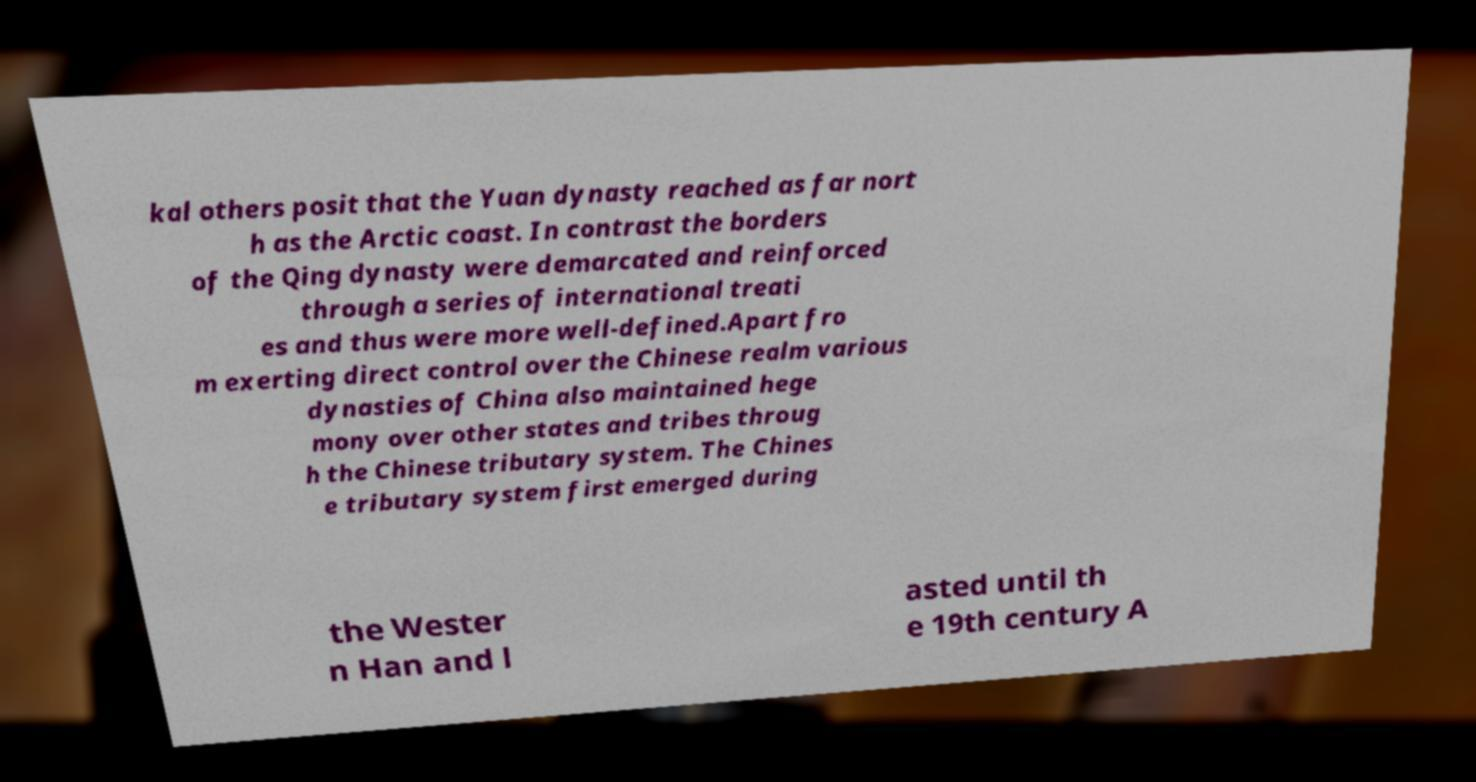Please read and relay the text visible in this image. What does it say? kal others posit that the Yuan dynasty reached as far nort h as the Arctic coast. In contrast the borders of the Qing dynasty were demarcated and reinforced through a series of international treati es and thus were more well-defined.Apart fro m exerting direct control over the Chinese realm various dynasties of China also maintained hege mony over other states and tribes throug h the Chinese tributary system. The Chines e tributary system first emerged during the Wester n Han and l asted until th e 19th century A 